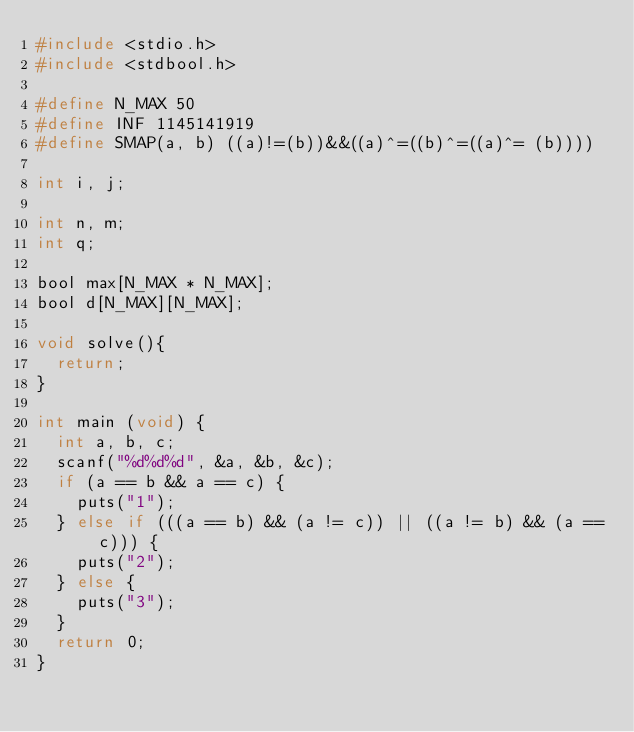Convert code to text. <code><loc_0><loc_0><loc_500><loc_500><_C_>#include <stdio.h>
#include <stdbool.h>

#define N_MAX 50
#define INF 1145141919
#define SMAP(a, b) ((a)!=(b))&&((a)^=((b)^=((a)^= (b))))

int i, j;

int n, m;
int q;

bool max[N_MAX * N_MAX];
bool d[N_MAX][N_MAX];

void solve(){
	return;
}

int main (void) {
	int a, b, c;
	scanf("%d%d%d", &a, &b, &c);
	if (a == b && a == c) {
		puts("1");
	} else if (((a == b) && (a != c)) || ((a != b) && (a == c))) {
		puts("2");
	} else {
		puts("3");
	}
	return 0;
}


</code> 